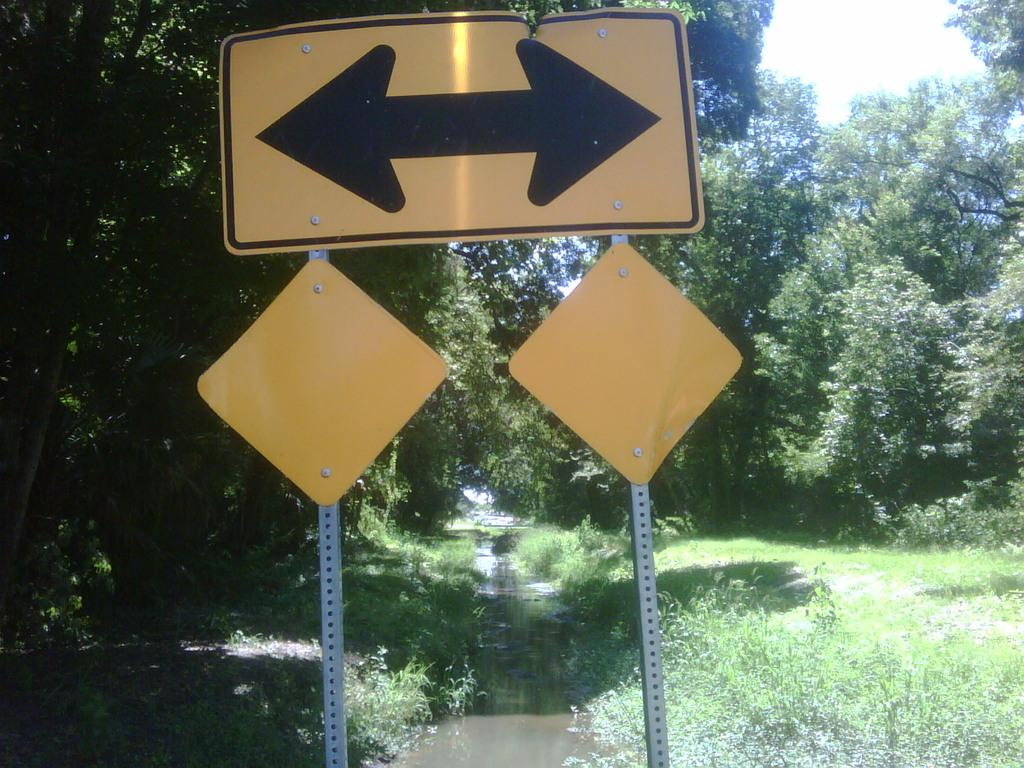What is located at the top side of the image? There is a sign board at the top side of the image. What can be seen at the bottom side of the image? There is water at the bottom side of the image. What type of natural elements are visible in the background of the image? There are trees in the background area of the image. Can you tell me how many credit cards are shown in the image? There are no credit cards present in the image. What type of seed can be seen growing near the trees in the image? There is no seed visible in the image; only trees are mentioned in the background. 